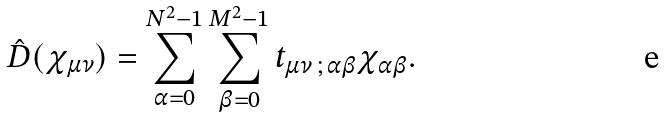<formula> <loc_0><loc_0><loc_500><loc_500>\hat { D } ( \chi _ { \mu \nu } ) = \sum _ { \alpha = 0 } ^ { N ^ { 2 } - 1 } \sum _ { \beta = 0 } ^ { M ^ { 2 } - 1 } t _ { \mu \nu \, ; \, \alpha \beta } \chi _ { \alpha \beta } .</formula> 